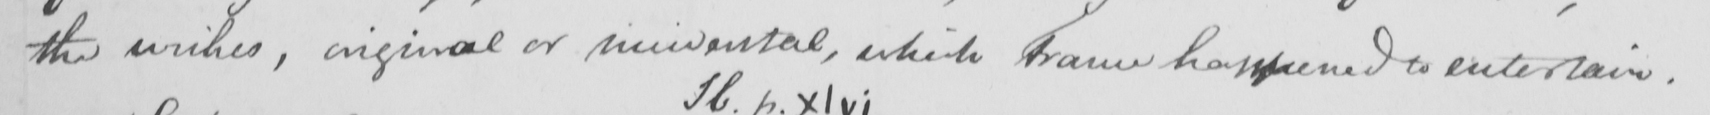Please provide the text content of this handwritten line. the wishes , original or incidental , which France happened to entertain . 